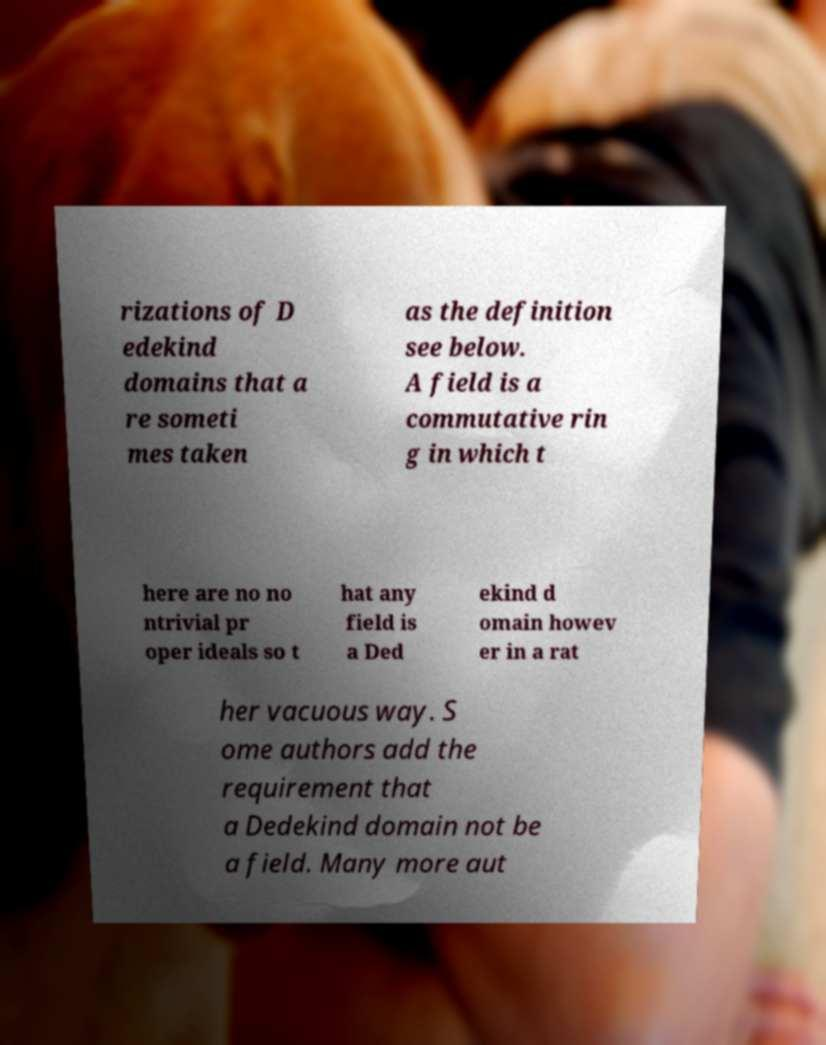Could you extract and type out the text from this image? rizations of D edekind domains that a re someti mes taken as the definition see below. A field is a commutative rin g in which t here are no no ntrivial pr oper ideals so t hat any field is a Ded ekind d omain howev er in a rat her vacuous way. S ome authors add the requirement that a Dedekind domain not be a field. Many more aut 